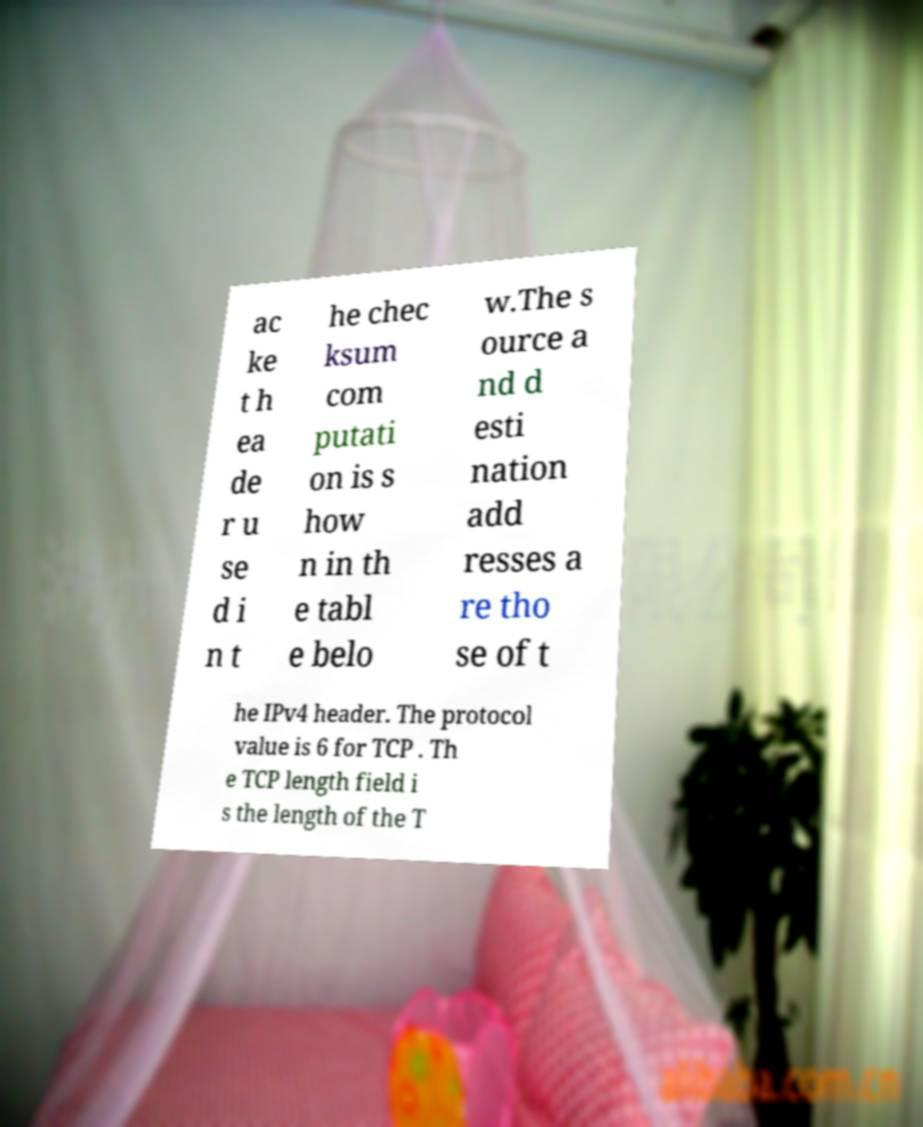There's text embedded in this image that I need extracted. Can you transcribe it verbatim? ac ke t h ea de r u se d i n t he chec ksum com putati on is s how n in th e tabl e belo w.The s ource a nd d esti nation add resses a re tho se of t he IPv4 header. The protocol value is 6 for TCP . Th e TCP length field i s the length of the T 